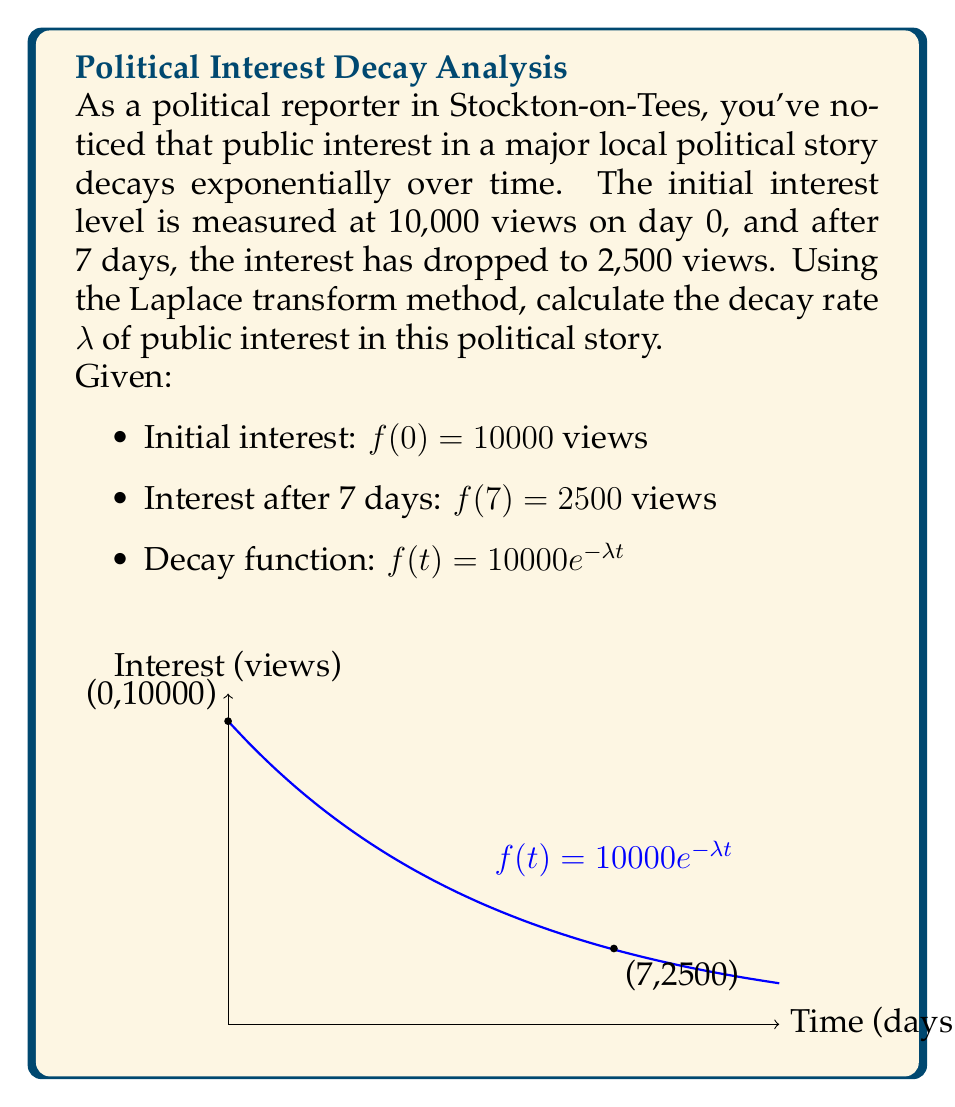Help me with this question. Let's solve this problem step-by-step using the Laplace transform method:

1) The given decay function is $f(t) = 10000e^{-λt}$. We need to find λ.

2) Using the given information:
   $f(0) = 10000 = 10000e^{-λ(0)} = 10000$ (This checks out)
   $f(7) = 2500 = 10000e^{-λ(7)}$

3) Let's focus on the equation from day 7:
   $2500 = 10000e^{-7λ}$

4) Divide both sides by 10000:
   $\frac{2500}{10000} = e^{-7λ}$
   $0.25 = e^{-7λ}$

5) Take the natural logarithm of both sides:
   $\ln(0.25) = \ln(e^{-7λ})$
   $\ln(0.25) = -7λ$

6) Solve for λ:
   $λ = -\frac{\ln(0.25)}{7}$

7) Calculate the value:
   $λ = -\frac{\ln(0.25)}{7} ≈ 0.1986$

Therefore, the decay rate λ is approximately 0.1986 per day.

8) To verify, let's check if this λ satisfies our original conditions:
   $f(7) = 10000e^{-0.1986 * 7} ≈ 2500$

This matches our given information, confirming our solution.
Answer: $λ ≈ 0.1986$ per day 